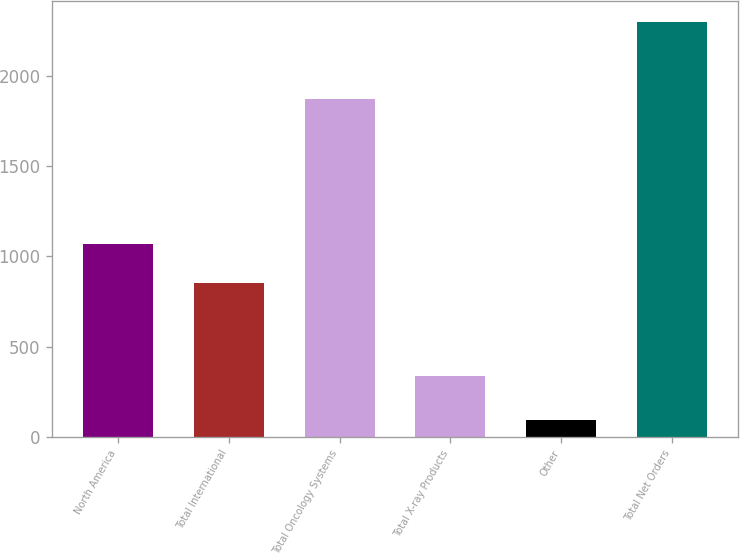<chart> <loc_0><loc_0><loc_500><loc_500><bar_chart><fcel>North America<fcel>Total International<fcel>Total Oncology Systems<fcel>Total X-ray Products<fcel>Other<fcel>Total Net Orders<nl><fcel>1071.8<fcel>851<fcel>1871<fcel>337<fcel>94<fcel>2302<nl></chart> 